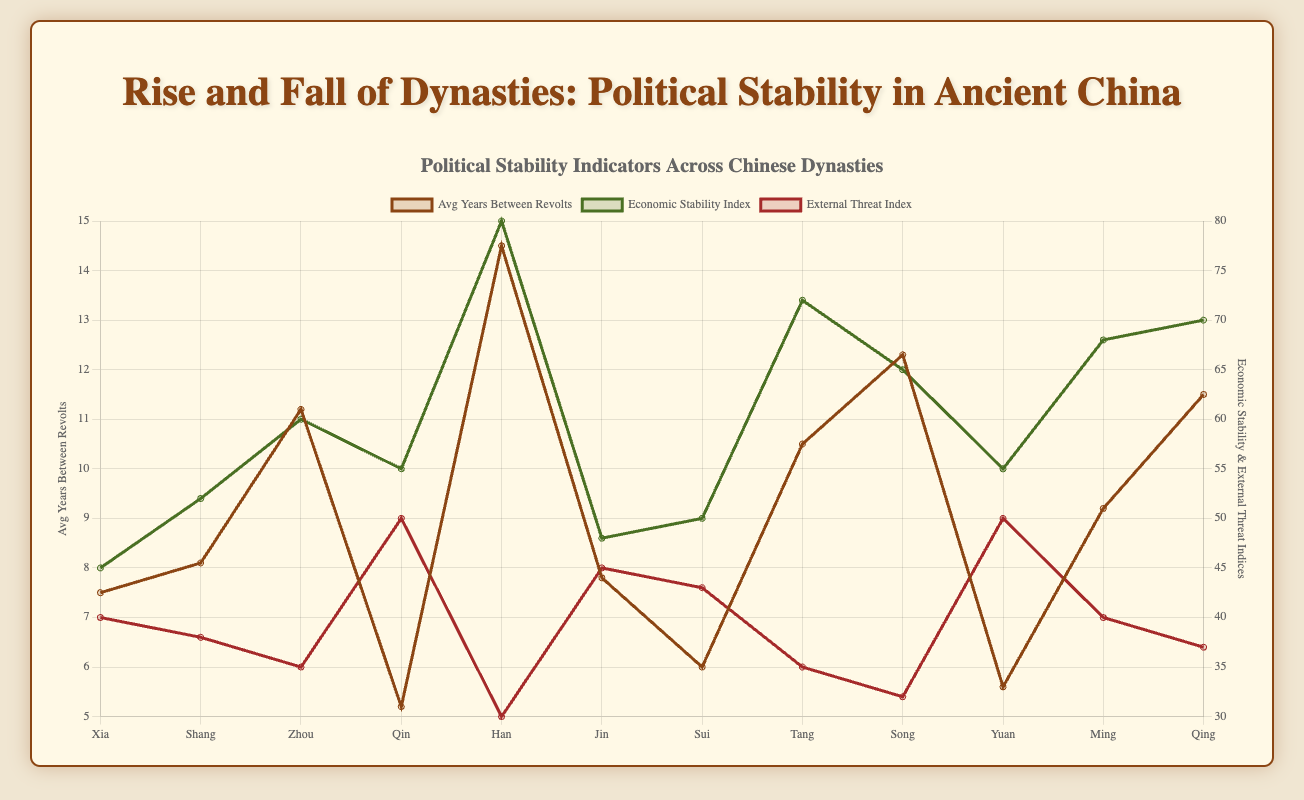Which dynasty had the highest average years between revolts? By visually examining the line labeled "Avg Years Between Revolts," we can identify the dynasty represented by the peak of this line. The Han dynasty has the highest peak at 14.5 years.
Answer: Han How does the economic stability index of the Han dynasty compare to that of the Qing dynasty? By comparing the two points on the line labeled "Economic Stability Index" for Han and Qing, Han's economic stability index is 80, while Qing's is 70. Hence, Han has a higher economic stability index.
Answer: Han has a higher economic stability index Which dynasties had an external threat index of 50, and how did their average years between revolts compare? First, identify the external threat index of 50 on the respective line. Both the Qin and Yuan dynasties have an external threat index of 50. Next, compare their average years between revolts: Qin has 5.2 years, and Yuan has 5.6 years. Yuan has slightly more years between revolts.
Answer: Qin: 5.2 years, Yuan: 5.6 years What is the overall trend in the economic stability indices across the dynasties? By observing the general direction of the "Economic Stability Index" line, we see a fluctuating but generally increasing trend from the Xia to Qing dynasty. The stability improves over time.
Answer: Increasing trend Which dynasty experienced the shortest average years between revolts, and what was its economic stability index? Identify the lowest point on the "Avg Years Between Revolts" line, which is the Qin dynasty with 5.2 years. Its economic stability index is 55.
Answer: Qin, with an economic stability index of 55 What is the difference in economic stability indices between the Shang and Tang dynasties? Compare the points for the Shang (52) and Tang (72) on the "Economic Stability Index" line. Calculate the difference: 72 - 52 = 20.
Answer: 20 Which dynasty had the smallest difference between its economic stability index and external threat index? Calculate the differences for each dynasty and identify the smallest value. For Zhou, it's 25 (60 - 35); for Han, it's 50 (80 - 30); and so on. The smallest difference is for Zhou.
Answer: Zhou Compare the economic stability index and external threat index of the Ming dynasty. Which one was higher and by how much? Compare the two indices for Ming: economic stability is 68, and external threat is 40. Calculate the difference: 68 - 40 = 28. The economic stability index is higher.
Answer: Economic stability index by 28 Considering the average years between revolts, how did the average stability of the Tang and Song dynasties compare? Compare the points on the "Avg Years Between Revolts" line for Tang (10.5) and Song (12.3). Song has a higher average stability.
Answer: Song has higher stability 